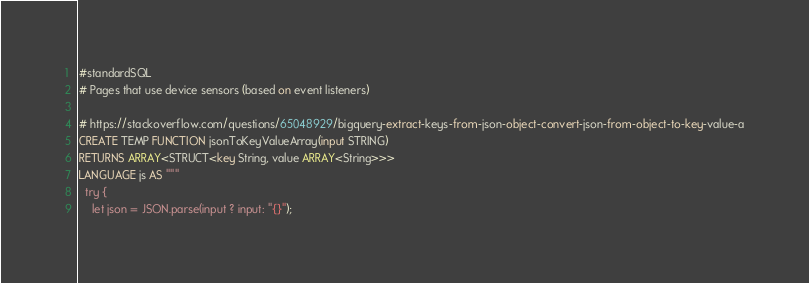<code> <loc_0><loc_0><loc_500><loc_500><_SQL_>#standardSQL
# Pages that use device sensors (based on event listeners)

# https://stackoverflow.com/questions/65048929/bigquery-extract-keys-from-json-object-convert-json-from-object-to-key-value-a
CREATE TEMP FUNCTION jsonToKeyValueArray(input STRING)
RETURNS ARRAY<STRUCT<key String, value ARRAY<String>>>
LANGUAGE js AS """
  try {
    let json = JSON.parse(input ? input: "{}");</code> 